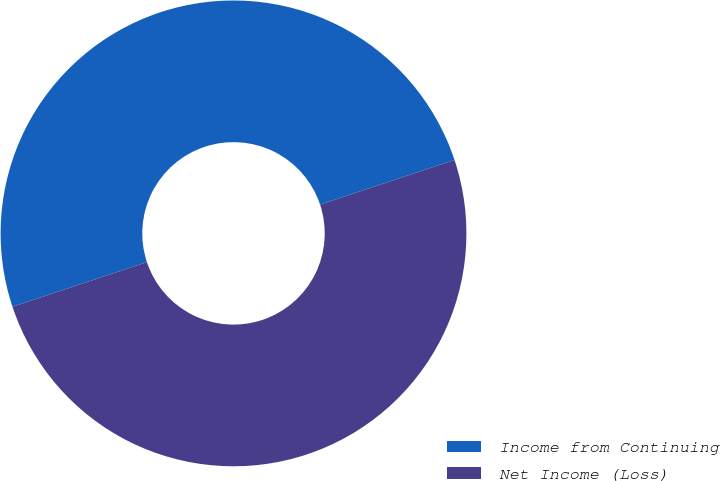Convert chart. <chart><loc_0><loc_0><loc_500><loc_500><pie_chart><fcel>Income from Continuing<fcel>Net Income (Loss)<nl><fcel>50.0%<fcel>50.0%<nl></chart> 